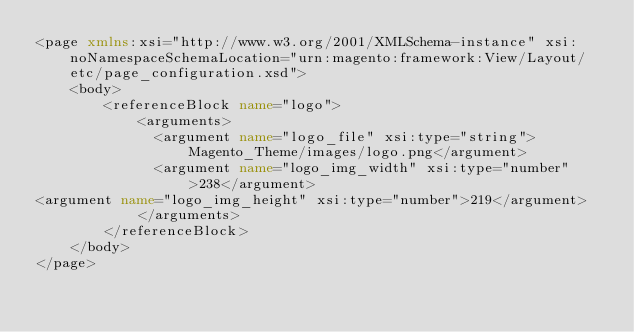<code> <loc_0><loc_0><loc_500><loc_500><_XML_><page xmlns:xsi="http://www.w3.org/2001/XMLSchema-instance" xsi:noNamespaceSchemaLocation="urn:magento:framework:View/Layout/etc/page_configuration.xsd">
    <body>
        <referenceBlock name="logo">
            <arguments>
              <argument name="logo_file" xsi:type="string">Magento_Theme/images/logo.png</argument>
              <argument name="logo_img_width" xsi:type="number">238</argument>
<argument name="logo_img_height" xsi:type="number">219</argument>
            </arguments>
        </referenceBlock>
    </body>
</page>
</code> 